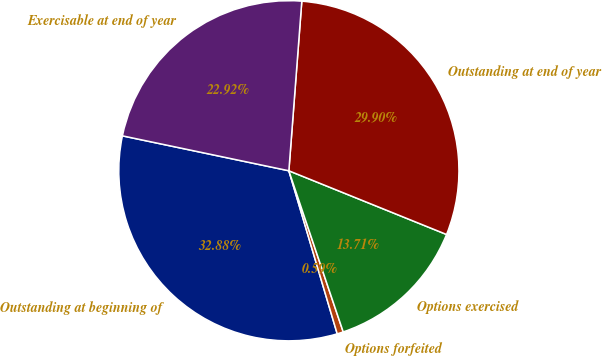Convert chart to OTSL. <chart><loc_0><loc_0><loc_500><loc_500><pie_chart><fcel>Outstanding at beginning of<fcel>Options forfeited<fcel>Options exercised<fcel>Outstanding at end of year<fcel>Exercisable at end of year<nl><fcel>32.88%<fcel>0.59%<fcel>13.71%<fcel>29.9%<fcel>22.92%<nl></chart> 